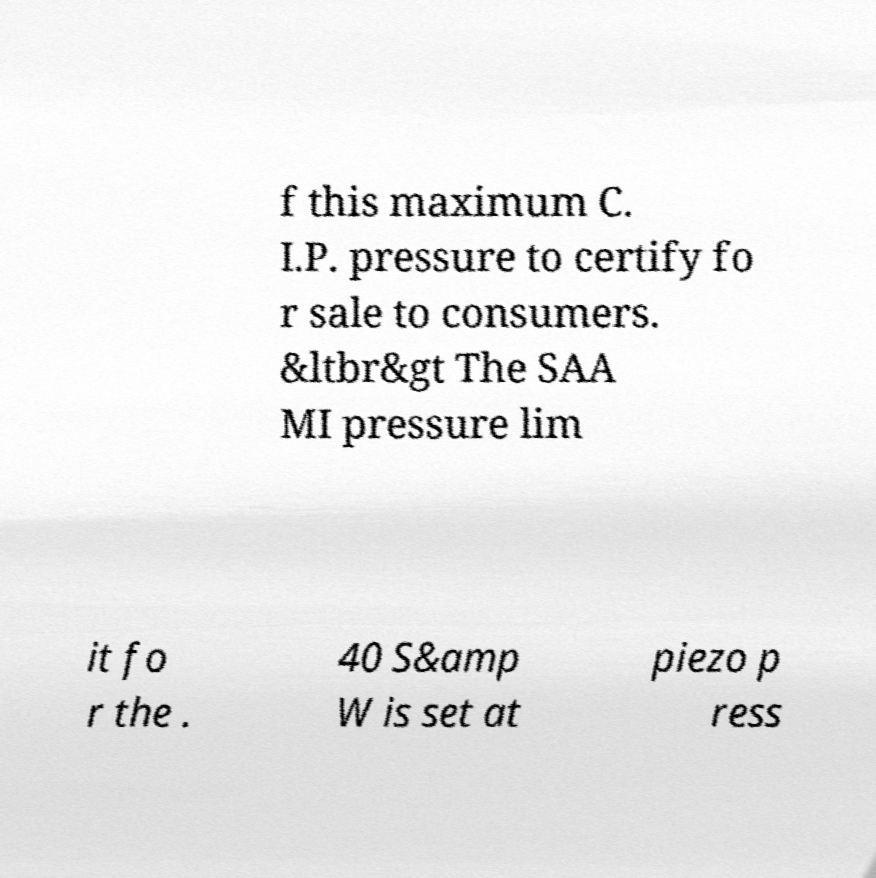What messages or text are displayed in this image? I need them in a readable, typed format. f this maximum C. I.P. pressure to certify fo r sale to consumers. &ltbr&gt The SAA MI pressure lim it fo r the . 40 S&amp W is set at piezo p ress 